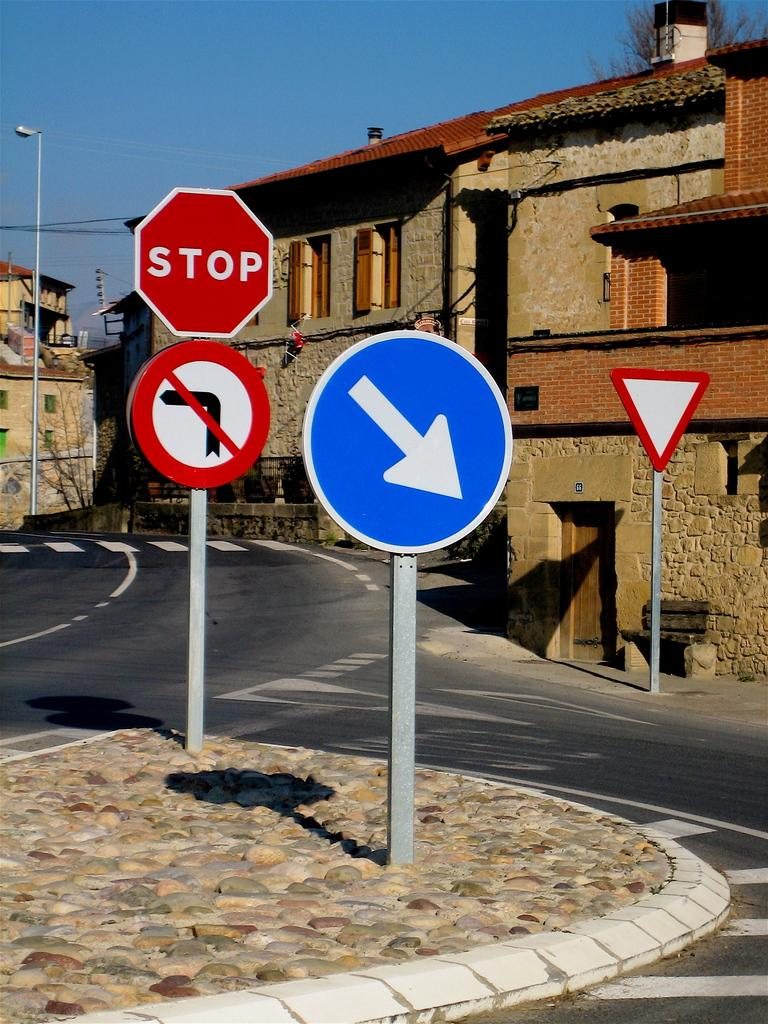<image>
Render a clear and concise summary of the photo. A red sign with the word Stop written on it and a blue sign with an arrow written on it. 